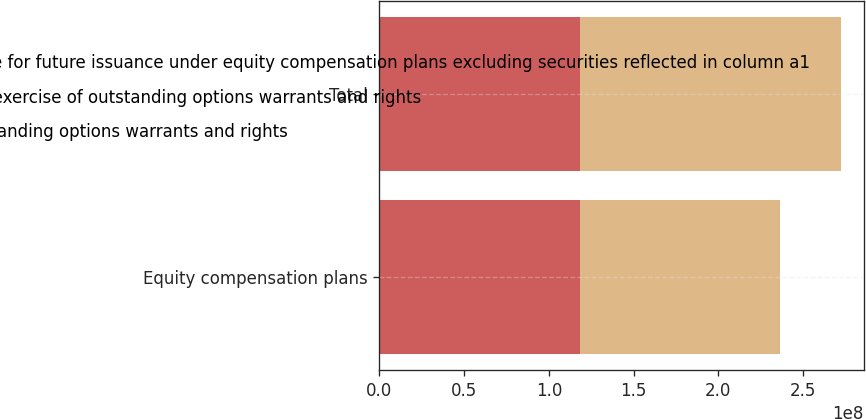<chart> <loc_0><loc_0><loc_500><loc_500><stacked_bar_chart><ecel><fcel>Equity compensation plans<fcel>Total<nl><fcel>c Number of securities remaining available for future issuance under equity compensation plans excluding securities reflected in column a1<fcel>1.18131e+08<fcel>1.18131e+08<nl><fcel>a Number of securities to be issued upon exercise of outstanding options warrants and rights<fcel>48.22<fcel>48.22<nl><fcel>b Weightedaverage exercise price of outstanding options warrants and rights<fcel>1.18131e+08<fcel>1.542e+08<nl></chart> 